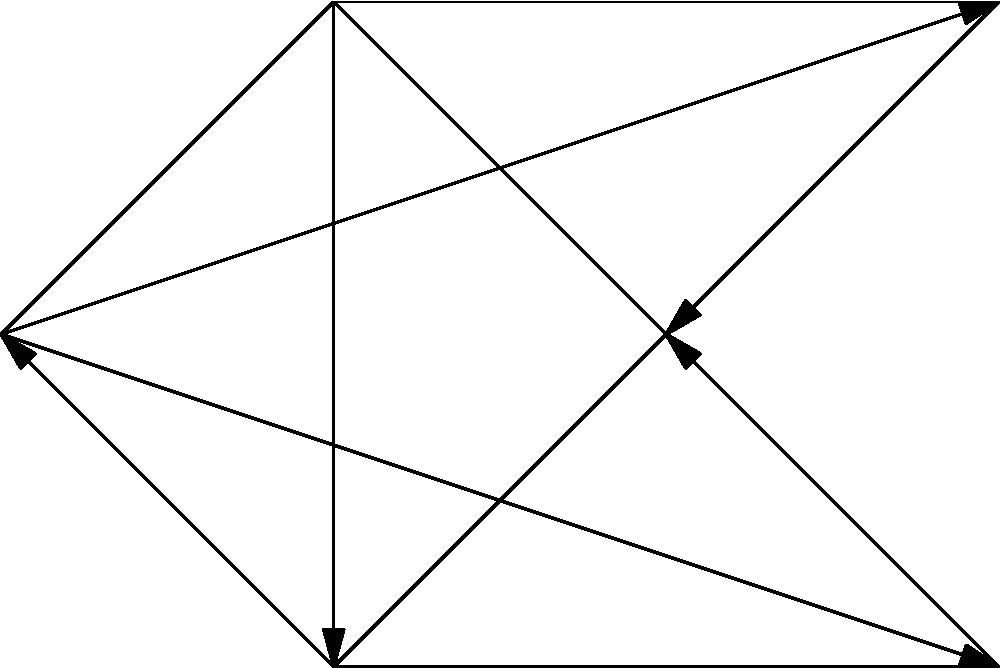In the network diagram representing interconnected LGBTQ+ policy areas, which policy area has the highest number of direct connections (edges) to other areas, and how many connections does it have? To answer this question, we need to analyze the network diagram and count the number of direct connections (edges) for each policy area. Let's go through each area:

1. Healthcare: Connected to Education, Housing, Legal Rights, and Social Services (4 connections)
2. Education: Connected to Healthcare, Employment, Legal Rights, and Housing (4 connections)
3. Employment: Connected to Education, Housing, Legal Rights, and Social Services (4 connections)
4. Housing: Connected to Healthcare, Education, and Employment (3 connections)
5. Legal Rights: Connected to Healthcare and Education (2 connections)
6. Social Services: Connected to Healthcare and Employment (2 connections)

After analyzing all the connections, we can see that Healthcare, Education, and Employment all have the highest number of direct connections, with 4 each. However, the question asks for a single policy area, so we need to choose one of these three.

In this case, we'll select Healthcare as it's the first one listed with the maximum number of connections.
Answer: Healthcare, 4 connections 